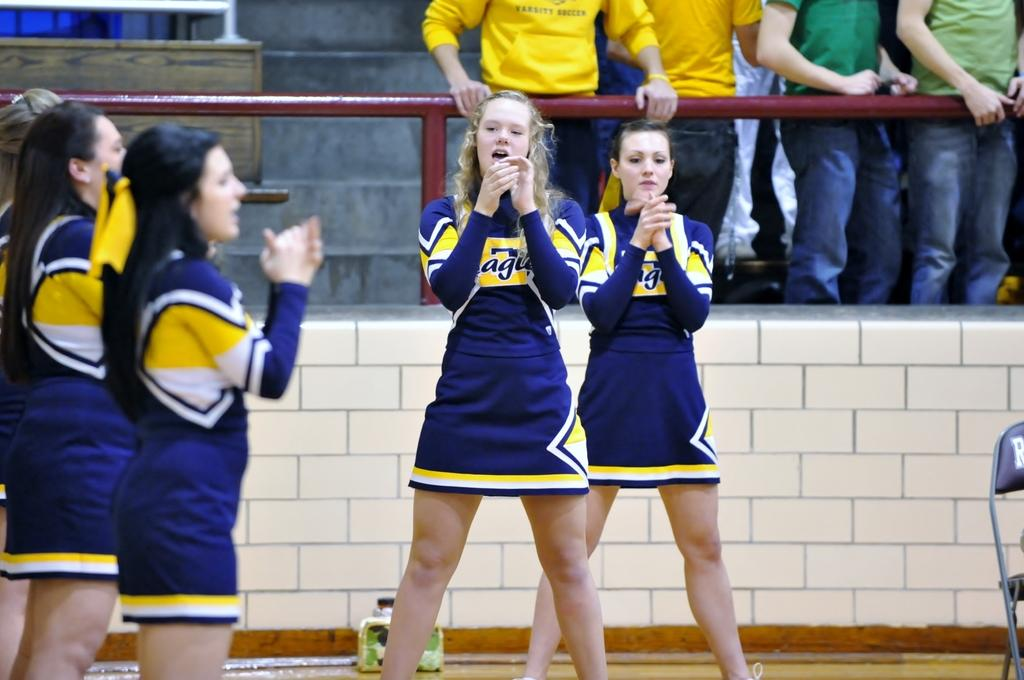<image>
Summarize the visual content of the image. cheerleaders wearing white, yellow and blue jerseys labeled 'eagles' 